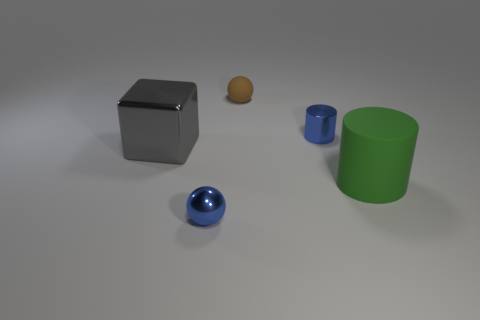How do the shadows help determine the light source? In the image, the shadows cast by the objects are pointing towards the bottom right, which suggests that the light source is located in the upper left area of the frame. Each object's shadow is elongated and somewhat soft at the edges, indicating a light source that isn't overly harsh or stark, likely diffused by some means. 